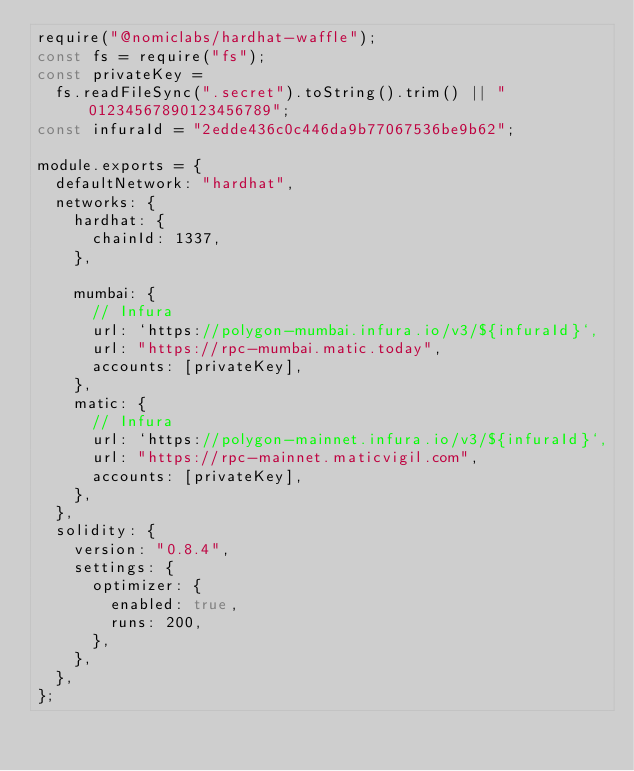<code> <loc_0><loc_0><loc_500><loc_500><_JavaScript_>require("@nomiclabs/hardhat-waffle");
const fs = require("fs");
const privateKey =
  fs.readFileSync(".secret").toString().trim() || "01234567890123456789";
const infuraId = "2edde436c0c446da9b77067536be9b62";

module.exports = {
  defaultNetwork: "hardhat",
  networks: {
    hardhat: {
      chainId: 1337,
    },

    mumbai: {
      // Infura
      url: `https://polygon-mumbai.infura.io/v3/${infuraId}`,
      url: "https://rpc-mumbai.matic.today",
      accounts: [privateKey],
    },
    matic: {
      // Infura
      url: `https://polygon-mainnet.infura.io/v3/${infuraId}`,
      url: "https://rpc-mainnet.maticvigil.com",
      accounts: [privateKey],
    },
  },
  solidity: {
    version: "0.8.4",
    settings: {
      optimizer: {
        enabled: true,
        runs: 200,
      },
    },
  },
};
</code> 